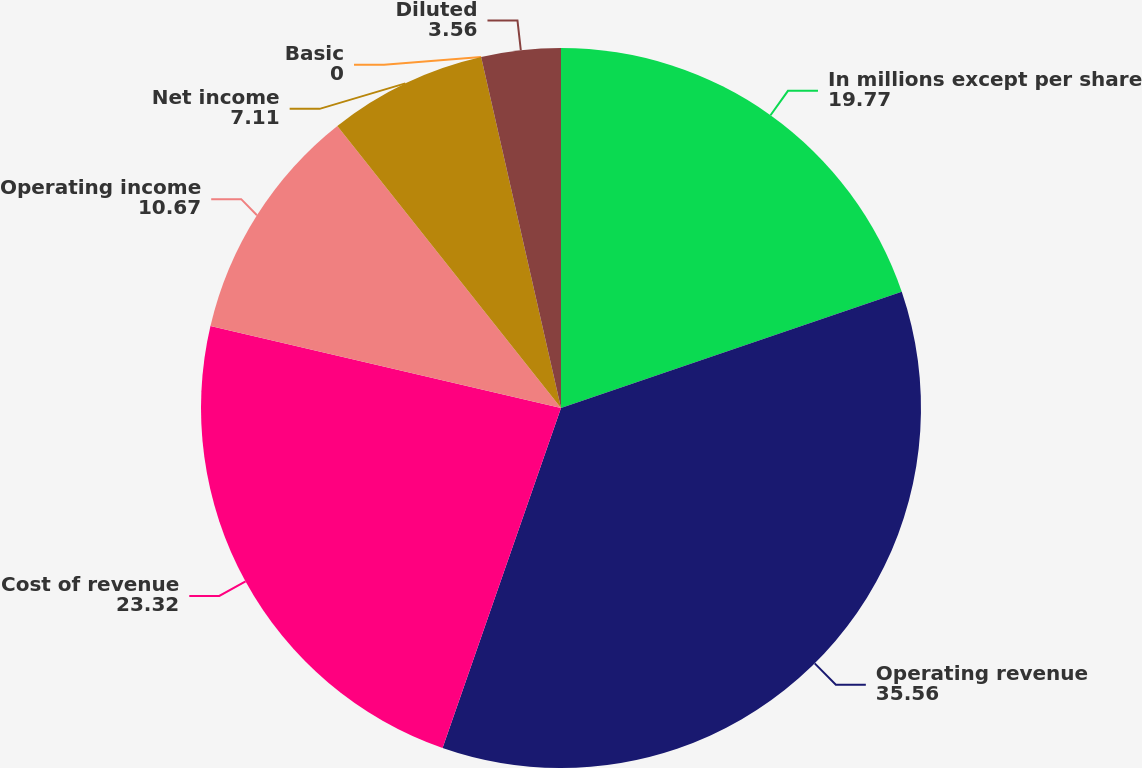Convert chart to OTSL. <chart><loc_0><loc_0><loc_500><loc_500><pie_chart><fcel>In millions except per share<fcel>Operating revenue<fcel>Cost of revenue<fcel>Operating income<fcel>Net income<fcel>Basic<fcel>Diluted<nl><fcel>19.77%<fcel>35.56%<fcel>23.32%<fcel>10.67%<fcel>7.11%<fcel>0.0%<fcel>3.56%<nl></chart> 